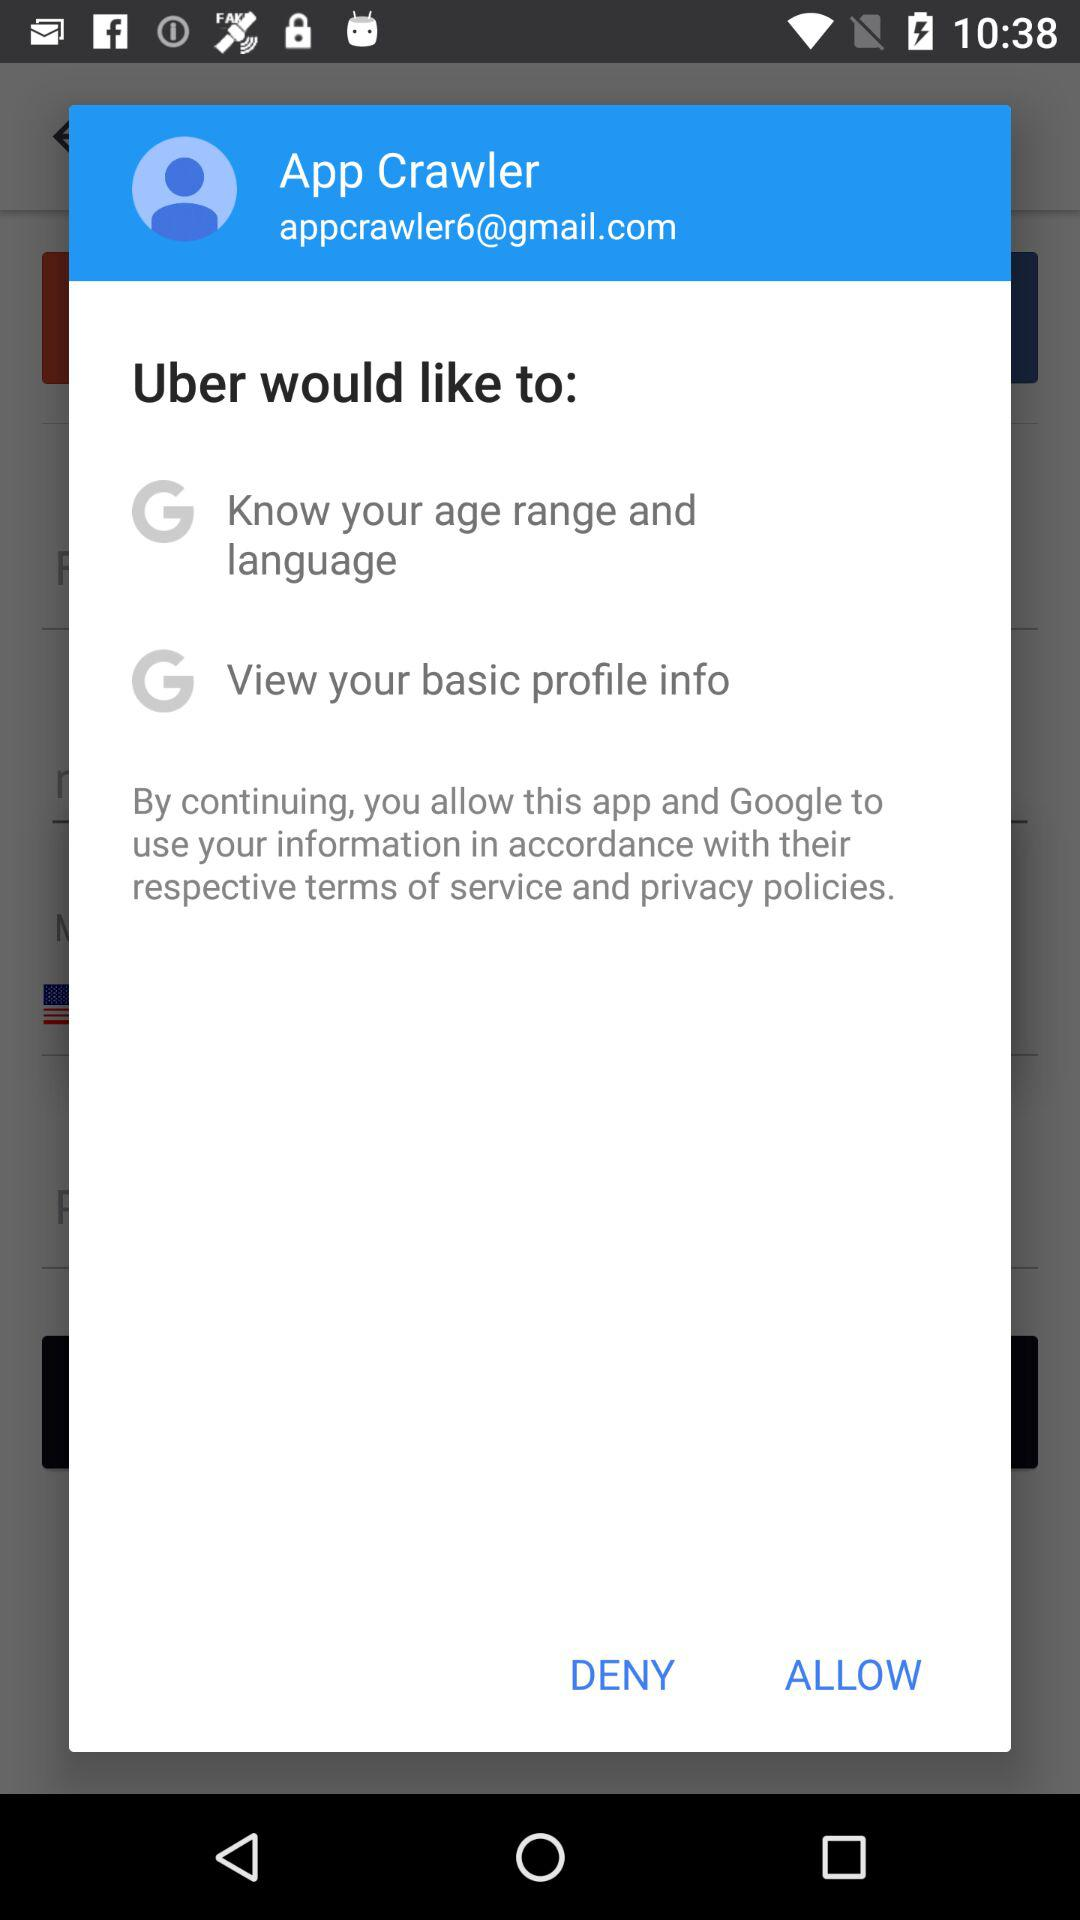What is the login email address? The email address to login with is appcrawler6@gmail.com. 